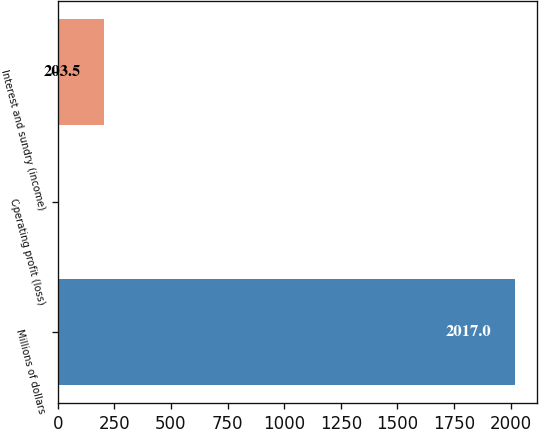Convert chart. <chart><loc_0><loc_0><loc_500><loc_500><bar_chart><fcel>Millions of dollars<fcel>Operating profit (loss)<fcel>Interest and sundry (income)<nl><fcel>2017<fcel>2<fcel>203.5<nl></chart> 